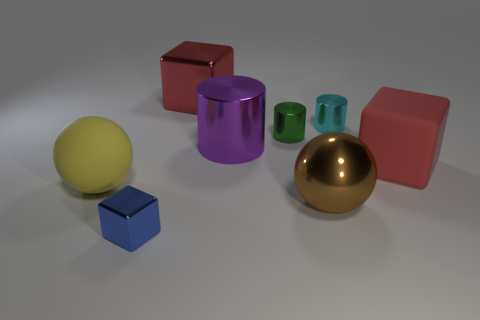Add 1 tiny blue rubber objects. How many objects exist? 9 Subtract 3 cylinders. How many cylinders are left? 0 Subtract all big red blocks. How many blocks are left? 1 Subtract all cubes. How many objects are left? 5 Subtract all metal objects. Subtract all big blocks. How many objects are left? 0 Add 6 red matte cubes. How many red matte cubes are left? 7 Add 7 small green rubber cylinders. How many small green rubber cylinders exist? 7 Subtract all blue blocks. How many blocks are left? 2 Subtract 0 yellow blocks. How many objects are left? 8 Subtract all brown cubes. Subtract all gray balls. How many cubes are left? 3 